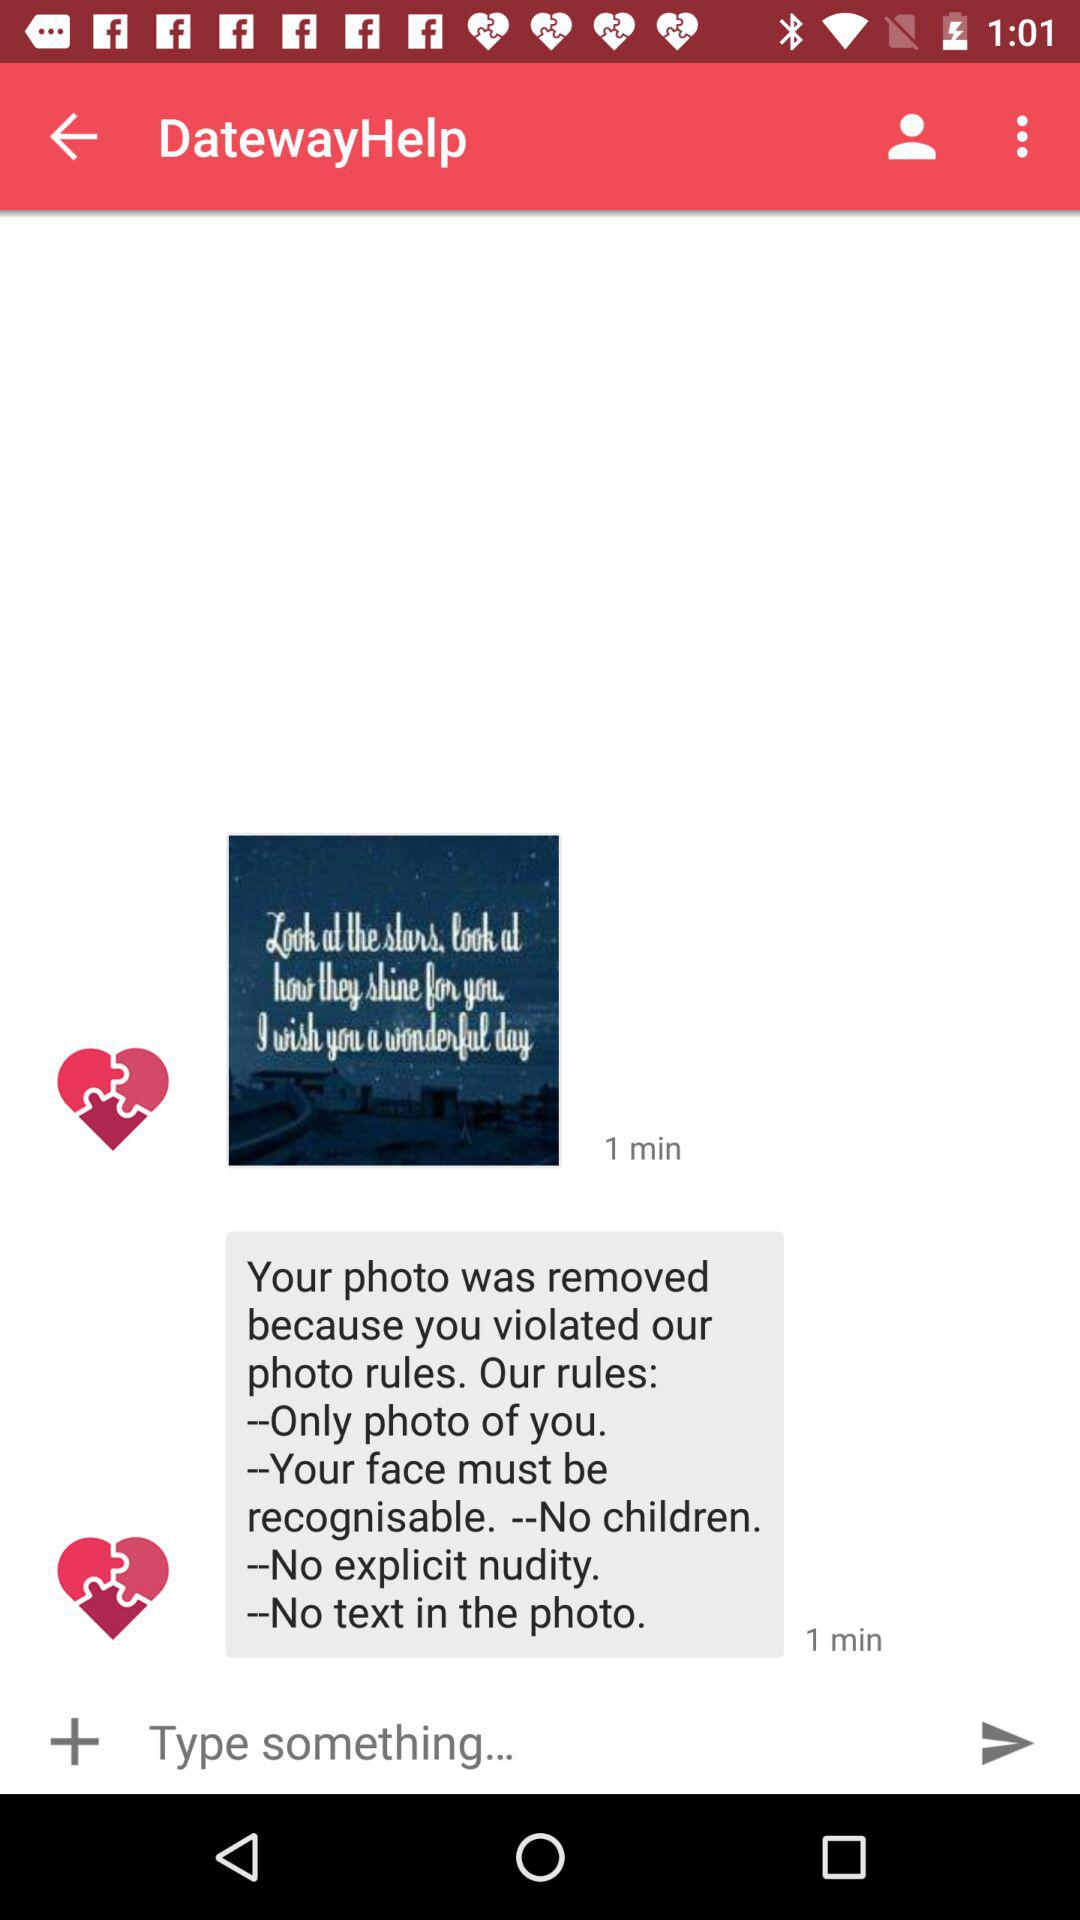How many hearts are there on the screen?
Answer the question using a single word or phrase. 2 